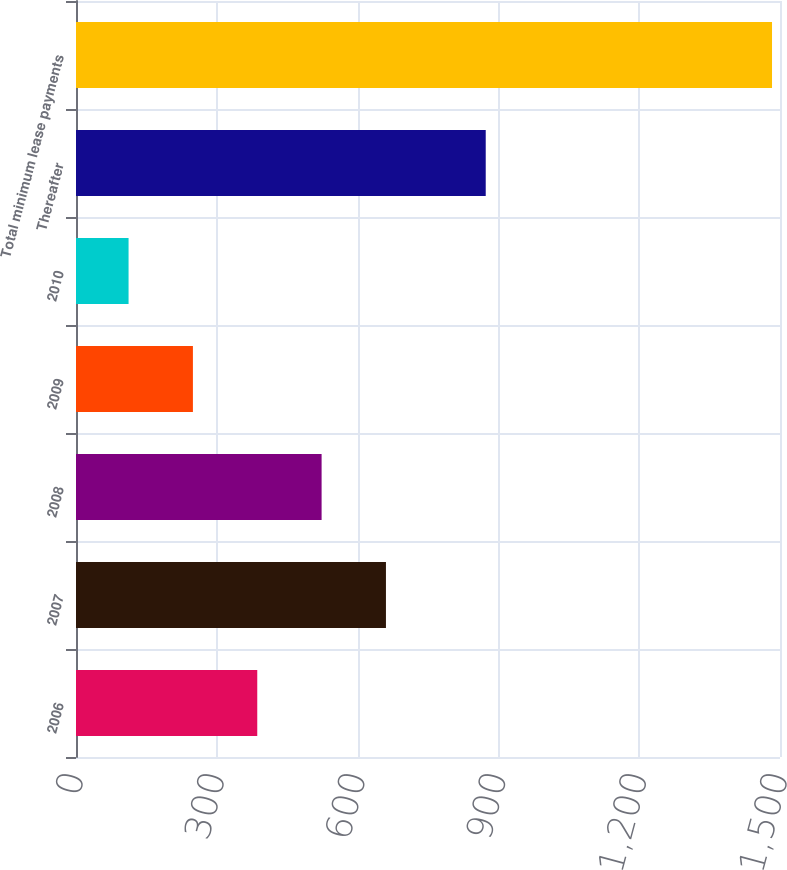<chart> <loc_0><loc_0><loc_500><loc_500><bar_chart><fcel>2006<fcel>2007<fcel>2008<fcel>2009<fcel>2010<fcel>Thereafter<fcel>Total minimum lease payments<nl><fcel>386.2<fcel>660.4<fcel>523.3<fcel>249.1<fcel>112<fcel>873<fcel>1483<nl></chart> 